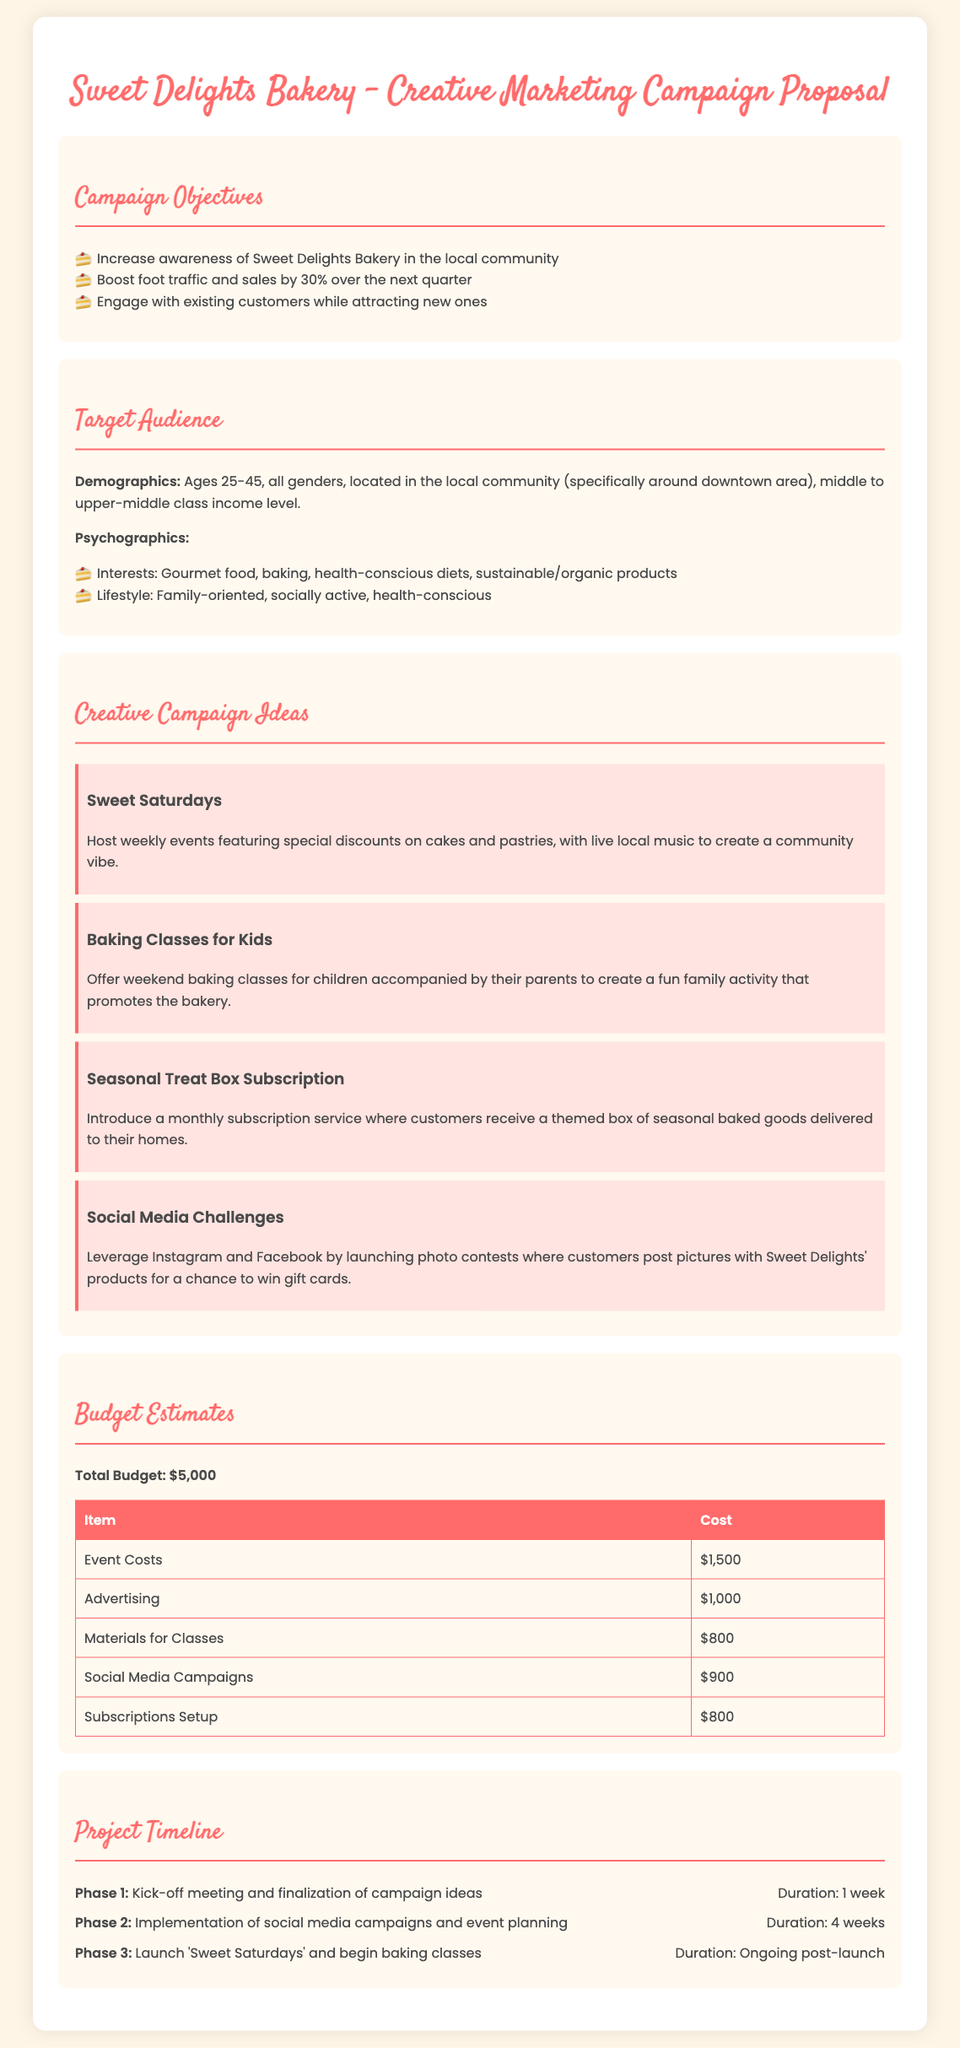what is the total budget for the campaign? The total budget is clearly stated in the budget section of the document as $5,000.
Answer: $5,000 what is the target age range for the audience? The target audience demographics specify ages 25-45.
Answer: 25-45 how many creative campaign ideas are proposed? The document lists four distinct creative campaign ideas under the campaign ideas section.
Answer: Four what is the duration of phase 2? Phase 2 is described in the timeline section with a specified duration of 4 weeks.
Answer: 4 weeks which campaign idea involves children's activities? The campaign idea that offers classes for children is mentioned as "Baking Classes for Kids."
Answer: Baking Classes for Kids what percentage increase in sales is aimed for the campaign? The objective states an aim to boost foot traffic and sales by 30%.
Answer: 30% what type of social media engagement is suggested? The proposal mentions launching photo contests on social media platforms as part of the engagement strategy.
Answer: Photo contests what is the cost of advertising in the budget estimates? The budget table provides the cost of advertising as $1,000.
Answer: $1,000 what is the focus of the 'Sweet Saturdays' campaign idea? The 'Sweet Saturdays' idea focuses on hosting weekly events featuring discounts and live music.
Answer: Weekly events with discounts and live music 